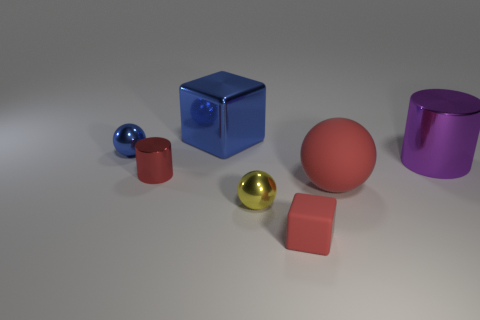What is the shape of the tiny matte thing?
Offer a very short reply. Cube. Is the tiny cube the same color as the big rubber thing?
Keep it short and to the point. Yes. The shiny cylinder that is the same color as the small matte thing is what size?
Ensure brevity in your answer.  Small. There is another thing that is the same shape as the purple shiny thing; what is its size?
Make the answer very short. Small. Is the number of objects that are behind the yellow ball less than the number of things?
Provide a short and direct response. Yes. How big is the red thing that is in front of the large red rubber ball?
Keep it short and to the point. Small. What is the color of the other tiny thing that is the same shape as the yellow object?
Keep it short and to the point. Blue. How many other things have the same color as the big matte object?
Ensure brevity in your answer.  2. There is a metallic sphere that is in front of the tiny sphere behind the red sphere; are there any things in front of it?
Give a very brief answer. Yes. How many balls are made of the same material as the big purple object?
Keep it short and to the point. 2. 